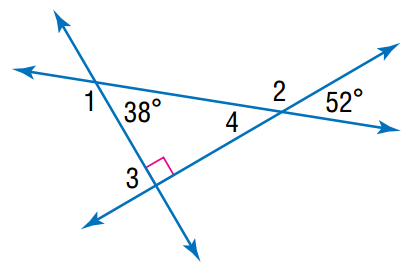Answer the mathemtical geometry problem and directly provide the correct option letter.
Question: Find the angle measure of \angle 2.
Choices: A: 128 B: 138 C: 142 D: 148 A 